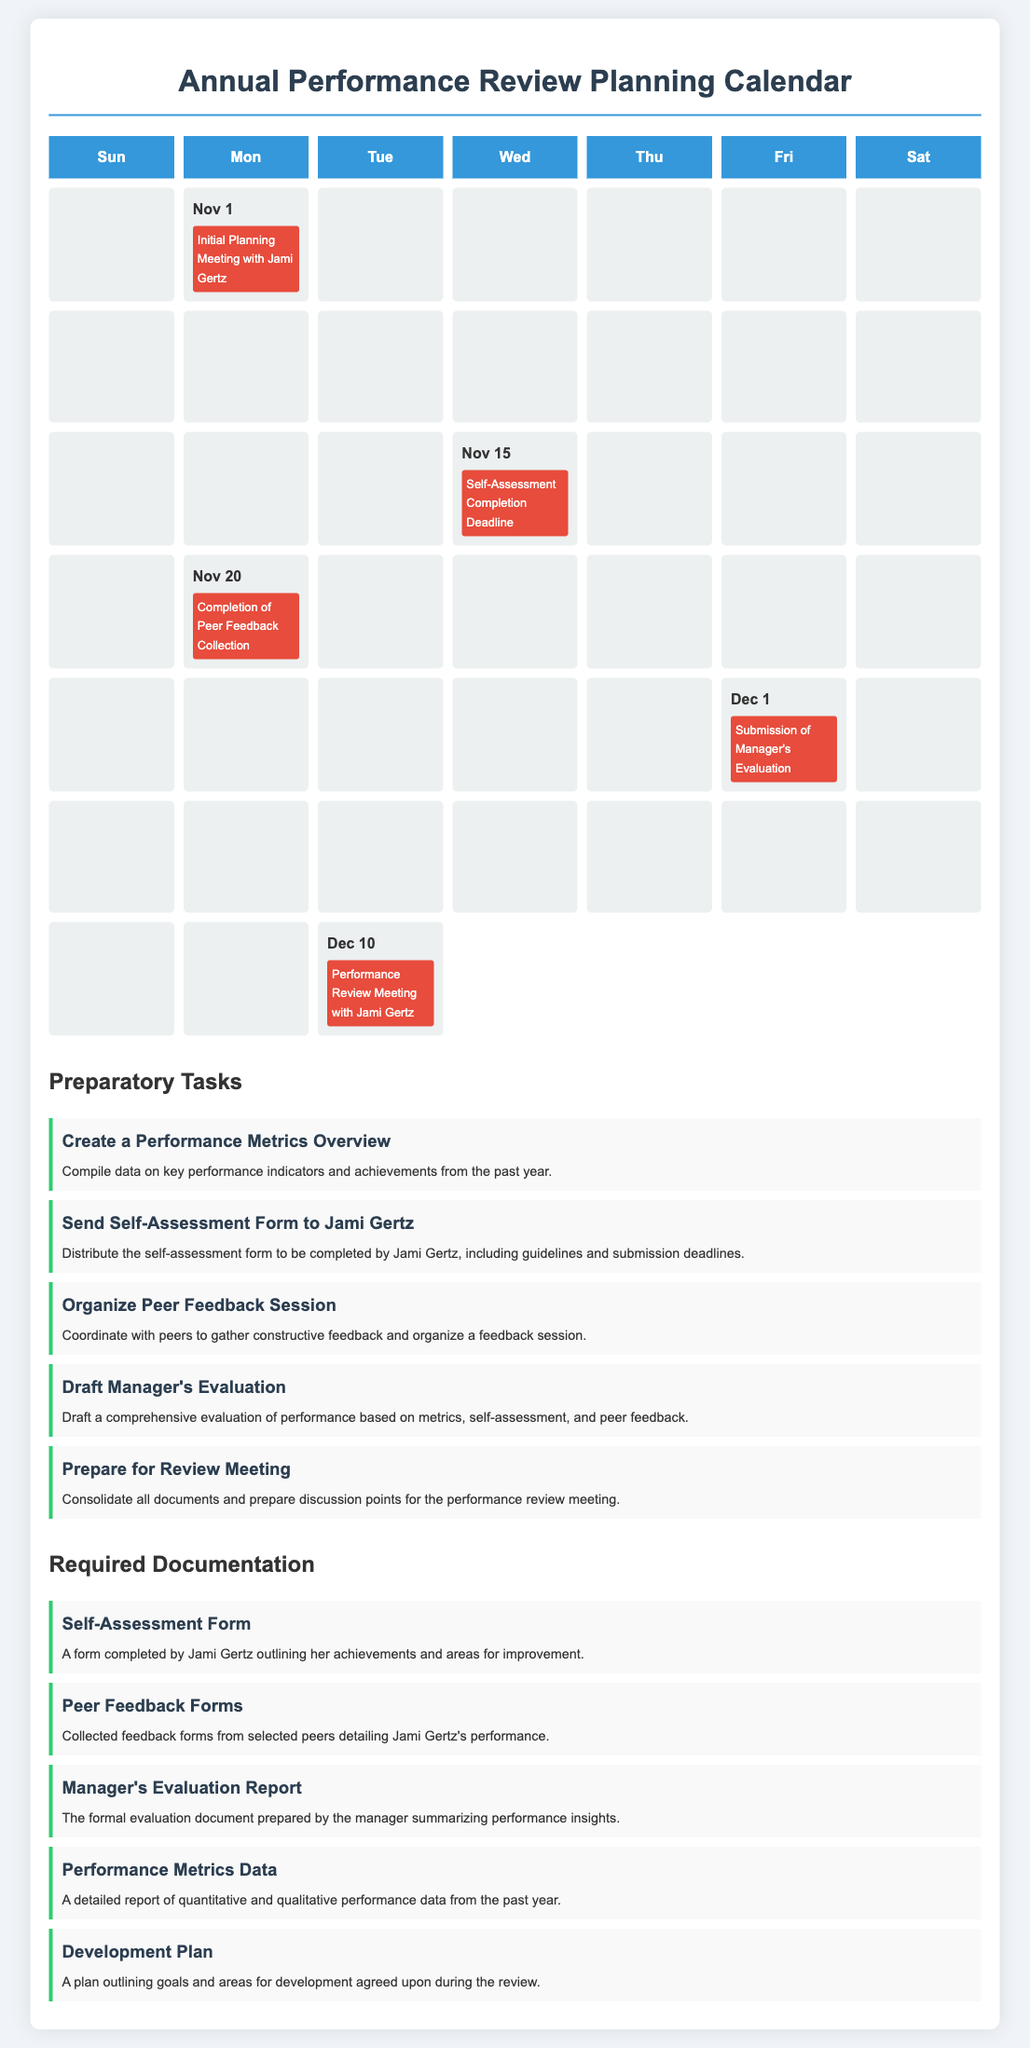What is the date of the initial planning meeting? The initial planning meeting with Jami Gertz is scheduled for Nov 1.
Answer: Nov 1 What is the deadline for self-assessment completion? The self-assessment completion deadline is on Nov 15.
Answer: Nov 15 When is the performance review meeting scheduled? The performance review meeting with Jami Gertz is set for Dec 10.
Answer: Dec 10 How many preparatory tasks are listed? There are five preparatory tasks listed in the document.
Answer: Five What type of document is the self-assessment form? The self-assessment form is a required documentation by Jami Gertz.
Answer: Required documentation What event occurs after the completion of peer feedback collection? After the completion of peer feedback collection, the submission of the manager's evaluation occurs.
Answer: Submission of Manager's Evaluation Which task involves consolidating documents? The task that involves consolidating documents is "Prepare for Review Meeting."
Answer: Prepare for Review Meeting What form is needed from peers? The required documentation from peers is the Peer Feedback Forms.
Answer: Peer Feedback Forms 